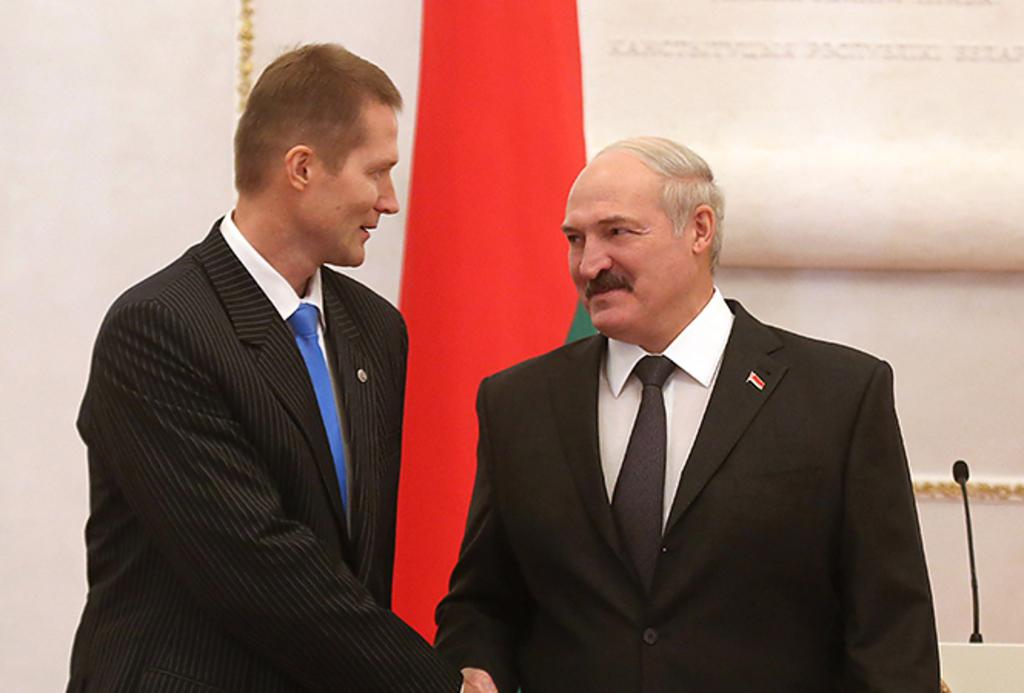How many men are in the image? There are two men in the image. What are the men wearing? Both men are wearing blazers and ties. What are the men doing in the image? The men are shaking hands and smiling. What can be seen in the background of the image? There is a flag, a microphone, and a wall visible in the background. What type of doctor can be seen treating a patient in the image? There is no doctor or patient present in the image; it features two men shaking hands and smiling. Can you tell me how many baths are visible in the image? There are no baths present in the image. 